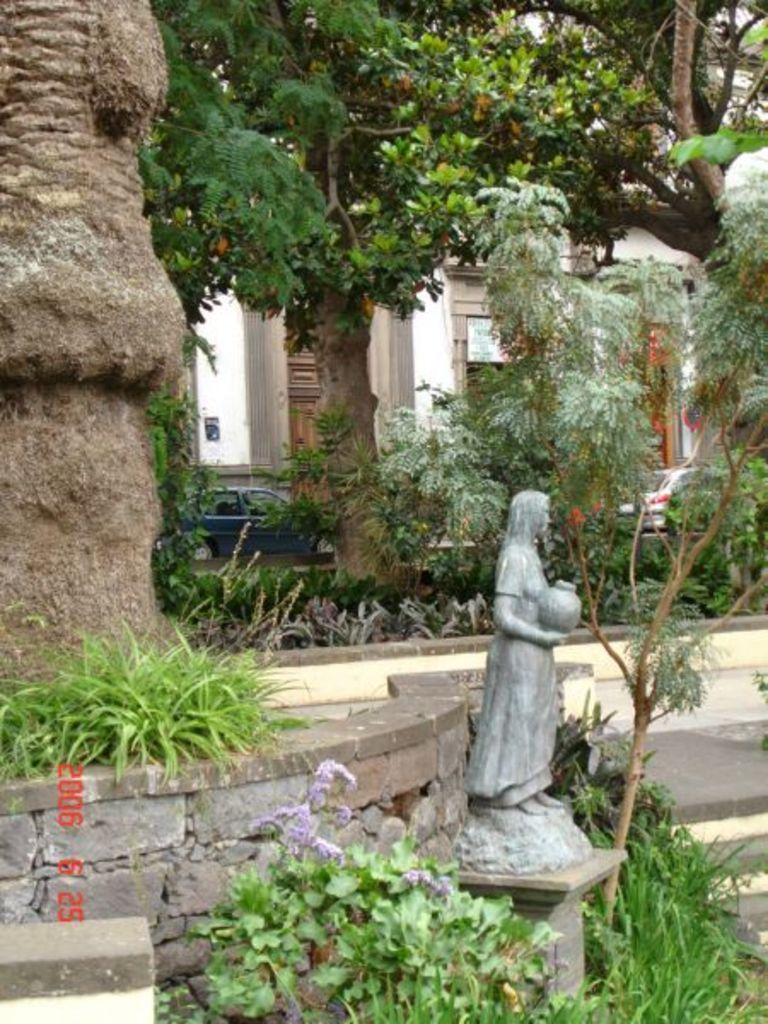What is the main subject in the image? There is a statue in the image. What type of natural elements can be seen in the image? There are trees and grass at the bottom of the image. What type of man-made structures are visible in the image? There is a building in the background of the image and cars in the image. What type of vegetation is present at the bottom of the image? There are plants at the bottom of the image. Can you tell me how many locks are on the statue in the image? There are no locks present on the statue in the image. What type of bomb is visible in the image? There is no bomb present in the image. 